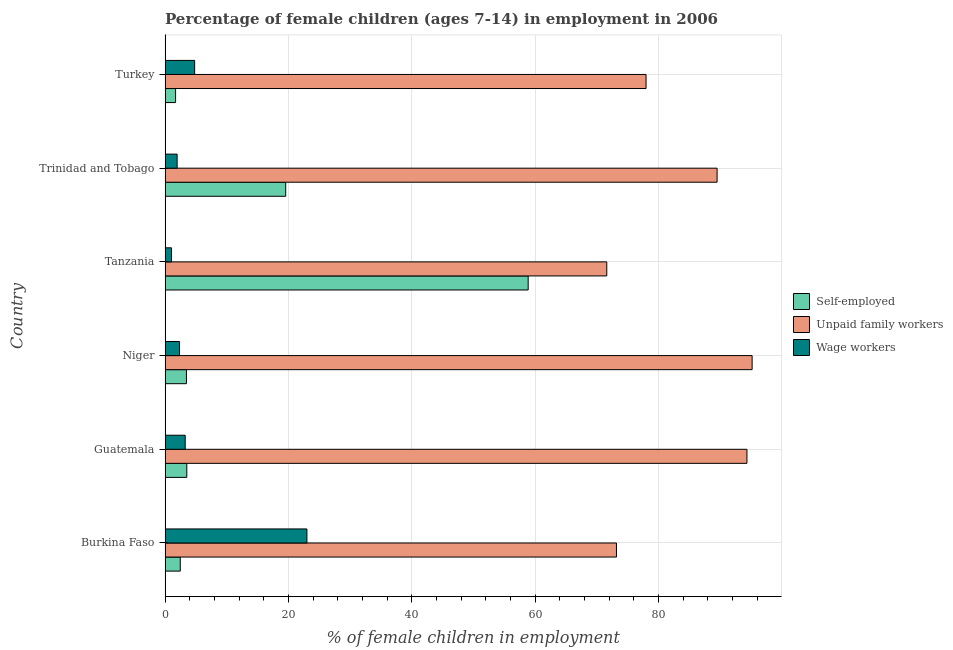How many bars are there on the 4th tick from the top?
Provide a succinct answer. 3. What is the label of the 2nd group of bars from the top?
Your response must be concise. Trinidad and Tobago. What is the percentage of children employed as unpaid family workers in Trinidad and Tobago?
Offer a very short reply. 89.52. Across all countries, what is the maximum percentage of self employed children?
Keep it short and to the point. 58.88. Across all countries, what is the minimum percentage of self employed children?
Provide a short and direct response. 1.7. In which country was the percentage of self employed children maximum?
Offer a very short reply. Tanzania. In which country was the percentage of self employed children minimum?
Provide a short and direct response. Turkey. What is the total percentage of children employed as wage workers in the graph?
Give a very brief answer. 36.38. What is the difference between the percentage of self employed children in Tanzania and that in Turkey?
Make the answer very short. 57.18. What is the difference between the percentage of children employed as wage workers in Tanzania and the percentage of self employed children in Burkina Faso?
Offer a very short reply. -1.42. What is the average percentage of self employed children per country?
Your answer should be compact. 14.93. What is the difference between the percentage of self employed children and percentage of children employed as unpaid family workers in Turkey?
Provide a succinct answer. -76.3. In how many countries, is the percentage of children employed as unpaid family workers greater than 40 %?
Your response must be concise. 6. What is the ratio of the percentage of self employed children in Tanzania to that in Trinidad and Tobago?
Provide a short and direct response. 3.01. Is the difference between the percentage of self employed children in Guatemala and Tanzania greater than the difference between the percentage of children employed as wage workers in Guatemala and Tanzania?
Make the answer very short. No. What is the difference between the highest and the second highest percentage of children employed as unpaid family workers?
Provide a succinct answer. 0.84. What is the difference between the highest and the lowest percentage of children employed as wage workers?
Your answer should be very brief. 21.96. In how many countries, is the percentage of self employed children greater than the average percentage of self employed children taken over all countries?
Offer a terse response. 2. Is the sum of the percentage of self employed children in Tanzania and Turkey greater than the maximum percentage of children employed as wage workers across all countries?
Provide a succinct answer. Yes. What does the 3rd bar from the top in Trinidad and Tobago represents?
Your response must be concise. Self-employed. What does the 2nd bar from the bottom in Tanzania represents?
Provide a short and direct response. Unpaid family workers. Is it the case that in every country, the sum of the percentage of self employed children and percentage of children employed as unpaid family workers is greater than the percentage of children employed as wage workers?
Your answer should be compact. Yes. How many bars are there?
Your response must be concise. 18. Are all the bars in the graph horizontal?
Your answer should be very brief. Yes. How many countries are there in the graph?
Keep it short and to the point. 6. What is the difference between two consecutive major ticks on the X-axis?
Your response must be concise. 20. Are the values on the major ticks of X-axis written in scientific E-notation?
Your response must be concise. No. Does the graph contain grids?
Give a very brief answer. Yes. How are the legend labels stacked?
Your answer should be very brief. Vertical. What is the title of the graph?
Offer a terse response. Percentage of female children (ages 7-14) in employment in 2006. Does "Injury" appear as one of the legend labels in the graph?
Your answer should be very brief. No. What is the label or title of the X-axis?
Offer a terse response. % of female children in employment. What is the % of female children in employment of Self-employed in Burkina Faso?
Ensure brevity in your answer.  2.46. What is the % of female children in employment in Unpaid family workers in Burkina Faso?
Your answer should be compact. 73.2. What is the % of female children in employment in Wage workers in Burkina Faso?
Your answer should be compact. 23. What is the % of female children in employment of Self-employed in Guatemala?
Give a very brief answer. 3.52. What is the % of female children in employment of Unpaid family workers in Guatemala?
Your answer should be compact. 94.36. What is the % of female children in employment of Wage workers in Guatemala?
Your answer should be very brief. 3.26. What is the % of female children in employment in Self-employed in Niger?
Offer a terse response. 3.46. What is the % of female children in employment in Unpaid family workers in Niger?
Your answer should be compact. 95.2. What is the % of female children in employment of Wage workers in Niger?
Your response must be concise. 2.34. What is the % of female children in employment of Self-employed in Tanzania?
Provide a short and direct response. 58.88. What is the % of female children in employment in Unpaid family workers in Tanzania?
Give a very brief answer. 71.63. What is the % of female children in employment in Self-employed in Trinidad and Tobago?
Ensure brevity in your answer.  19.56. What is the % of female children in employment in Unpaid family workers in Trinidad and Tobago?
Your response must be concise. 89.52. What is the % of female children in employment in Wage workers in Trinidad and Tobago?
Your answer should be compact. 1.95. What is the % of female children in employment in Self-employed in Turkey?
Provide a succinct answer. 1.7. What is the % of female children in employment in Unpaid family workers in Turkey?
Ensure brevity in your answer.  78. What is the % of female children in employment of Wage workers in Turkey?
Make the answer very short. 4.79. Across all countries, what is the maximum % of female children in employment of Self-employed?
Offer a terse response. 58.88. Across all countries, what is the maximum % of female children in employment in Unpaid family workers?
Offer a very short reply. 95.2. Across all countries, what is the maximum % of female children in employment of Wage workers?
Your answer should be very brief. 23. Across all countries, what is the minimum % of female children in employment of Unpaid family workers?
Provide a short and direct response. 71.63. What is the total % of female children in employment of Self-employed in the graph?
Make the answer very short. 89.58. What is the total % of female children in employment in Unpaid family workers in the graph?
Offer a terse response. 501.91. What is the total % of female children in employment in Wage workers in the graph?
Your answer should be very brief. 36.38. What is the difference between the % of female children in employment of Self-employed in Burkina Faso and that in Guatemala?
Give a very brief answer. -1.06. What is the difference between the % of female children in employment in Unpaid family workers in Burkina Faso and that in Guatemala?
Your answer should be very brief. -21.16. What is the difference between the % of female children in employment of Wage workers in Burkina Faso and that in Guatemala?
Give a very brief answer. 19.74. What is the difference between the % of female children in employment of Unpaid family workers in Burkina Faso and that in Niger?
Your answer should be very brief. -22. What is the difference between the % of female children in employment of Wage workers in Burkina Faso and that in Niger?
Your answer should be very brief. 20.66. What is the difference between the % of female children in employment in Self-employed in Burkina Faso and that in Tanzania?
Your answer should be compact. -56.42. What is the difference between the % of female children in employment in Unpaid family workers in Burkina Faso and that in Tanzania?
Your response must be concise. 1.57. What is the difference between the % of female children in employment of Wage workers in Burkina Faso and that in Tanzania?
Offer a very short reply. 21.96. What is the difference between the % of female children in employment in Self-employed in Burkina Faso and that in Trinidad and Tobago?
Ensure brevity in your answer.  -17.1. What is the difference between the % of female children in employment of Unpaid family workers in Burkina Faso and that in Trinidad and Tobago?
Ensure brevity in your answer.  -16.32. What is the difference between the % of female children in employment in Wage workers in Burkina Faso and that in Trinidad and Tobago?
Offer a very short reply. 21.05. What is the difference between the % of female children in employment of Self-employed in Burkina Faso and that in Turkey?
Your answer should be compact. 0.76. What is the difference between the % of female children in employment in Wage workers in Burkina Faso and that in Turkey?
Keep it short and to the point. 18.21. What is the difference between the % of female children in employment of Unpaid family workers in Guatemala and that in Niger?
Ensure brevity in your answer.  -0.84. What is the difference between the % of female children in employment of Self-employed in Guatemala and that in Tanzania?
Ensure brevity in your answer.  -55.36. What is the difference between the % of female children in employment of Unpaid family workers in Guatemala and that in Tanzania?
Your response must be concise. 22.73. What is the difference between the % of female children in employment in Wage workers in Guatemala and that in Tanzania?
Your answer should be very brief. 2.22. What is the difference between the % of female children in employment in Self-employed in Guatemala and that in Trinidad and Tobago?
Give a very brief answer. -16.04. What is the difference between the % of female children in employment in Unpaid family workers in Guatemala and that in Trinidad and Tobago?
Provide a succinct answer. 4.84. What is the difference between the % of female children in employment of Wage workers in Guatemala and that in Trinidad and Tobago?
Ensure brevity in your answer.  1.31. What is the difference between the % of female children in employment of Self-employed in Guatemala and that in Turkey?
Provide a short and direct response. 1.82. What is the difference between the % of female children in employment in Unpaid family workers in Guatemala and that in Turkey?
Make the answer very short. 16.36. What is the difference between the % of female children in employment in Wage workers in Guatemala and that in Turkey?
Provide a short and direct response. -1.53. What is the difference between the % of female children in employment in Self-employed in Niger and that in Tanzania?
Offer a very short reply. -55.42. What is the difference between the % of female children in employment in Unpaid family workers in Niger and that in Tanzania?
Your answer should be very brief. 23.57. What is the difference between the % of female children in employment of Self-employed in Niger and that in Trinidad and Tobago?
Provide a short and direct response. -16.1. What is the difference between the % of female children in employment of Unpaid family workers in Niger and that in Trinidad and Tobago?
Provide a succinct answer. 5.68. What is the difference between the % of female children in employment of Wage workers in Niger and that in Trinidad and Tobago?
Offer a terse response. 0.39. What is the difference between the % of female children in employment in Self-employed in Niger and that in Turkey?
Provide a short and direct response. 1.76. What is the difference between the % of female children in employment of Wage workers in Niger and that in Turkey?
Keep it short and to the point. -2.45. What is the difference between the % of female children in employment in Self-employed in Tanzania and that in Trinidad and Tobago?
Give a very brief answer. 39.32. What is the difference between the % of female children in employment of Unpaid family workers in Tanzania and that in Trinidad and Tobago?
Make the answer very short. -17.89. What is the difference between the % of female children in employment of Wage workers in Tanzania and that in Trinidad and Tobago?
Give a very brief answer. -0.91. What is the difference between the % of female children in employment in Self-employed in Tanzania and that in Turkey?
Give a very brief answer. 57.18. What is the difference between the % of female children in employment of Unpaid family workers in Tanzania and that in Turkey?
Your answer should be very brief. -6.37. What is the difference between the % of female children in employment of Wage workers in Tanzania and that in Turkey?
Offer a very short reply. -3.75. What is the difference between the % of female children in employment of Self-employed in Trinidad and Tobago and that in Turkey?
Give a very brief answer. 17.86. What is the difference between the % of female children in employment in Unpaid family workers in Trinidad and Tobago and that in Turkey?
Provide a succinct answer. 11.52. What is the difference between the % of female children in employment of Wage workers in Trinidad and Tobago and that in Turkey?
Give a very brief answer. -2.84. What is the difference between the % of female children in employment in Self-employed in Burkina Faso and the % of female children in employment in Unpaid family workers in Guatemala?
Ensure brevity in your answer.  -91.9. What is the difference between the % of female children in employment in Self-employed in Burkina Faso and the % of female children in employment in Wage workers in Guatemala?
Give a very brief answer. -0.8. What is the difference between the % of female children in employment of Unpaid family workers in Burkina Faso and the % of female children in employment of Wage workers in Guatemala?
Provide a short and direct response. 69.94. What is the difference between the % of female children in employment of Self-employed in Burkina Faso and the % of female children in employment of Unpaid family workers in Niger?
Your answer should be compact. -92.74. What is the difference between the % of female children in employment of Self-employed in Burkina Faso and the % of female children in employment of Wage workers in Niger?
Ensure brevity in your answer.  0.12. What is the difference between the % of female children in employment of Unpaid family workers in Burkina Faso and the % of female children in employment of Wage workers in Niger?
Give a very brief answer. 70.86. What is the difference between the % of female children in employment of Self-employed in Burkina Faso and the % of female children in employment of Unpaid family workers in Tanzania?
Ensure brevity in your answer.  -69.17. What is the difference between the % of female children in employment in Self-employed in Burkina Faso and the % of female children in employment in Wage workers in Tanzania?
Make the answer very short. 1.42. What is the difference between the % of female children in employment in Unpaid family workers in Burkina Faso and the % of female children in employment in Wage workers in Tanzania?
Your answer should be compact. 72.16. What is the difference between the % of female children in employment in Self-employed in Burkina Faso and the % of female children in employment in Unpaid family workers in Trinidad and Tobago?
Ensure brevity in your answer.  -87.06. What is the difference between the % of female children in employment in Self-employed in Burkina Faso and the % of female children in employment in Wage workers in Trinidad and Tobago?
Make the answer very short. 0.51. What is the difference between the % of female children in employment of Unpaid family workers in Burkina Faso and the % of female children in employment of Wage workers in Trinidad and Tobago?
Your response must be concise. 71.25. What is the difference between the % of female children in employment of Self-employed in Burkina Faso and the % of female children in employment of Unpaid family workers in Turkey?
Keep it short and to the point. -75.54. What is the difference between the % of female children in employment of Self-employed in Burkina Faso and the % of female children in employment of Wage workers in Turkey?
Ensure brevity in your answer.  -2.33. What is the difference between the % of female children in employment in Unpaid family workers in Burkina Faso and the % of female children in employment in Wage workers in Turkey?
Offer a terse response. 68.41. What is the difference between the % of female children in employment of Self-employed in Guatemala and the % of female children in employment of Unpaid family workers in Niger?
Ensure brevity in your answer.  -91.68. What is the difference between the % of female children in employment of Self-employed in Guatemala and the % of female children in employment of Wage workers in Niger?
Your answer should be very brief. 1.18. What is the difference between the % of female children in employment in Unpaid family workers in Guatemala and the % of female children in employment in Wage workers in Niger?
Offer a terse response. 92.02. What is the difference between the % of female children in employment in Self-employed in Guatemala and the % of female children in employment in Unpaid family workers in Tanzania?
Provide a short and direct response. -68.11. What is the difference between the % of female children in employment in Self-employed in Guatemala and the % of female children in employment in Wage workers in Tanzania?
Your answer should be compact. 2.48. What is the difference between the % of female children in employment in Unpaid family workers in Guatemala and the % of female children in employment in Wage workers in Tanzania?
Offer a very short reply. 93.32. What is the difference between the % of female children in employment in Self-employed in Guatemala and the % of female children in employment in Unpaid family workers in Trinidad and Tobago?
Your response must be concise. -86. What is the difference between the % of female children in employment in Self-employed in Guatemala and the % of female children in employment in Wage workers in Trinidad and Tobago?
Offer a very short reply. 1.57. What is the difference between the % of female children in employment in Unpaid family workers in Guatemala and the % of female children in employment in Wage workers in Trinidad and Tobago?
Your response must be concise. 92.41. What is the difference between the % of female children in employment in Self-employed in Guatemala and the % of female children in employment in Unpaid family workers in Turkey?
Provide a succinct answer. -74.48. What is the difference between the % of female children in employment of Self-employed in Guatemala and the % of female children in employment of Wage workers in Turkey?
Provide a short and direct response. -1.27. What is the difference between the % of female children in employment of Unpaid family workers in Guatemala and the % of female children in employment of Wage workers in Turkey?
Your answer should be very brief. 89.57. What is the difference between the % of female children in employment in Self-employed in Niger and the % of female children in employment in Unpaid family workers in Tanzania?
Provide a short and direct response. -68.17. What is the difference between the % of female children in employment of Self-employed in Niger and the % of female children in employment of Wage workers in Tanzania?
Provide a succinct answer. 2.42. What is the difference between the % of female children in employment of Unpaid family workers in Niger and the % of female children in employment of Wage workers in Tanzania?
Ensure brevity in your answer.  94.16. What is the difference between the % of female children in employment of Self-employed in Niger and the % of female children in employment of Unpaid family workers in Trinidad and Tobago?
Your response must be concise. -86.06. What is the difference between the % of female children in employment in Self-employed in Niger and the % of female children in employment in Wage workers in Trinidad and Tobago?
Offer a very short reply. 1.51. What is the difference between the % of female children in employment in Unpaid family workers in Niger and the % of female children in employment in Wage workers in Trinidad and Tobago?
Provide a succinct answer. 93.25. What is the difference between the % of female children in employment of Self-employed in Niger and the % of female children in employment of Unpaid family workers in Turkey?
Ensure brevity in your answer.  -74.54. What is the difference between the % of female children in employment of Self-employed in Niger and the % of female children in employment of Wage workers in Turkey?
Keep it short and to the point. -1.33. What is the difference between the % of female children in employment of Unpaid family workers in Niger and the % of female children in employment of Wage workers in Turkey?
Ensure brevity in your answer.  90.41. What is the difference between the % of female children in employment in Self-employed in Tanzania and the % of female children in employment in Unpaid family workers in Trinidad and Tobago?
Give a very brief answer. -30.64. What is the difference between the % of female children in employment of Self-employed in Tanzania and the % of female children in employment of Wage workers in Trinidad and Tobago?
Make the answer very short. 56.93. What is the difference between the % of female children in employment of Unpaid family workers in Tanzania and the % of female children in employment of Wage workers in Trinidad and Tobago?
Your response must be concise. 69.68. What is the difference between the % of female children in employment of Self-employed in Tanzania and the % of female children in employment of Unpaid family workers in Turkey?
Your answer should be very brief. -19.12. What is the difference between the % of female children in employment of Self-employed in Tanzania and the % of female children in employment of Wage workers in Turkey?
Make the answer very short. 54.09. What is the difference between the % of female children in employment of Unpaid family workers in Tanzania and the % of female children in employment of Wage workers in Turkey?
Your response must be concise. 66.84. What is the difference between the % of female children in employment in Self-employed in Trinidad and Tobago and the % of female children in employment in Unpaid family workers in Turkey?
Give a very brief answer. -58.44. What is the difference between the % of female children in employment of Self-employed in Trinidad and Tobago and the % of female children in employment of Wage workers in Turkey?
Make the answer very short. 14.77. What is the difference between the % of female children in employment in Unpaid family workers in Trinidad and Tobago and the % of female children in employment in Wage workers in Turkey?
Provide a short and direct response. 84.73. What is the average % of female children in employment in Self-employed per country?
Your answer should be very brief. 14.93. What is the average % of female children in employment of Unpaid family workers per country?
Your answer should be compact. 83.65. What is the average % of female children in employment of Wage workers per country?
Give a very brief answer. 6.06. What is the difference between the % of female children in employment of Self-employed and % of female children in employment of Unpaid family workers in Burkina Faso?
Offer a very short reply. -70.74. What is the difference between the % of female children in employment in Self-employed and % of female children in employment in Wage workers in Burkina Faso?
Offer a terse response. -20.54. What is the difference between the % of female children in employment of Unpaid family workers and % of female children in employment of Wage workers in Burkina Faso?
Keep it short and to the point. 50.2. What is the difference between the % of female children in employment of Self-employed and % of female children in employment of Unpaid family workers in Guatemala?
Offer a terse response. -90.84. What is the difference between the % of female children in employment in Self-employed and % of female children in employment in Wage workers in Guatemala?
Give a very brief answer. 0.26. What is the difference between the % of female children in employment of Unpaid family workers and % of female children in employment of Wage workers in Guatemala?
Give a very brief answer. 91.1. What is the difference between the % of female children in employment of Self-employed and % of female children in employment of Unpaid family workers in Niger?
Provide a short and direct response. -91.74. What is the difference between the % of female children in employment of Self-employed and % of female children in employment of Wage workers in Niger?
Offer a terse response. 1.12. What is the difference between the % of female children in employment in Unpaid family workers and % of female children in employment in Wage workers in Niger?
Provide a succinct answer. 92.86. What is the difference between the % of female children in employment in Self-employed and % of female children in employment in Unpaid family workers in Tanzania?
Keep it short and to the point. -12.75. What is the difference between the % of female children in employment in Self-employed and % of female children in employment in Wage workers in Tanzania?
Your response must be concise. 57.84. What is the difference between the % of female children in employment of Unpaid family workers and % of female children in employment of Wage workers in Tanzania?
Your answer should be very brief. 70.59. What is the difference between the % of female children in employment of Self-employed and % of female children in employment of Unpaid family workers in Trinidad and Tobago?
Offer a very short reply. -69.96. What is the difference between the % of female children in employment of Self-employed and % of female children in employment of Wage workers in Trinidad and Tobago?
Your answer should be compact. 17.61. What is the difference between the % of female children in employment of Unpaid family workers and % of female children in employment of Wage workers in Trinidad and Tobago?
Your answer should be compact. 87.57. What is the difference between the % of female children in employment in Self-employed and % of female children in employment in Unpaid family workers in Turkey?
Your answer should be compact. -76.3. What is the difference between the % of female children in employment in Self-employed and % of female children in employment in Wage workers in Turkey?
Your answer should be compact. -3.09. What is the difference between the % of female children in employment of Unpaid family workers and % of female children in employment of Wage workers in Turkey?
Ensure brevity in your answer.  73.21. What is the ratio of the % of female children in employment of Self-employed in Burkina Faso to that in Guatemala?
Give a very brief answer. 0.7. What is the ratio of the % of female children in employment of Unpaid family workers in Burkina Faso to that in Guatemala?
Make the answer very short. 0.78. What is the ratio of the % of female children in employment of Wage workers in Burkina Faso to that in Guatemala?
Offer a terse response. 7.06. What is the ratio of the % of female children in employment in Self-employed in Burkina Faso to that in Niger?
Keep it short and to the point. 0.71. What is the ratio of the % of female children in employment of Unpaid family workers in Burkina Faso to that in Niger?
Ensure brevity in your answer.  0.77. What is the ratio of the % of female children in employment in Wage workers in Burkina Faso to that in Niger?
Your response must be concise. 9.83. What is the ratio of the % of female children in employment of Self-employed in Burkina Faso to that in Tanzania?
Keep it short and to the point. 0.04. What is the ratio of the % of female children in employment of Unpaid family workers in Burkina Faso to that in Tanzania?
Provide a short and direct response. 1.02. What is the ratio of the % of female children in employment in Wage workers in Burkina Faso to that in Tanzania?
Make the answer very short. 22.12. What is the ratio of the % of female children in employment in Self-employed in Burkina Faso to that in Trinidad and Tobago?
Provide a succinct answer. 0.13. What is the ratio of the % of female children in employment in Unpaid family workers in Burkina Faso to that in Trinidad and Tobago?
Give a very brief answer. 0.82. What is the ratio of the % of female children in employment in Wage workers in Burkina Faso to that in Trinidad and Tobago?
Offer a very short reply. 11.79. What is the ratio of the % of female children in employment of Self-employed in Burkina Faso to that in Turkey?
Your answer should be compact. 1.45. What is the ratio of the % of female children in employment of Unpaid family workers in Burkina Faso to that in Turkey?
Give a very brief answer. 0.94. What is the ratio of the % of female children in employment in Wage workers in Burkina Faso to that in Turkey?
Make the answer very short. 4.8. What is the ratio of the % of female children in employment in Self-employed in Guatemala to that in Niger?
Provide a succinct answer. 1.02. What is the ratio of the % of female children in employment in Wage workers in Guatemala to that in Niger?
Provide a short and direct response. 1.39. What is the ratio of the % of female children in employment of Self-employed in Guatemala to that in Tanzania?
Keep it short and to the point. 0.06. What is the ratio of the % of female children in employment of Unpaid family workers in Guatemala to that in Tanzania?
Provide a short and direct response. 1.32. What is the ratio of the % of female children in employment in Wage workers in Guatemala to that in Tanzania?
Ensure brevity in your answer.  3.13. What is the ratio of the % of female children in employment in Self-employed in Guatemala to that in Trinidad and Tobago?
Ensure brevity in your answer.  0.18. What is the ratio of the % of female children in employment in Unpaid family workers in Guatemala to that in Trinidad and Tobago?
Make the answer very short. 1.05. What is the ratio of the % of female children in employment in Wage workers in Guatemala to that in Trinidad and Tobago?
Provide a succinct answer. 1.67. What is the ratio of the % of female children in employment of Self-employed in Guatemala to that in Turkey?
Give a very brief answer. 2.07. What is the ratio of the % of female children in employment of Unpaid family workers in Guatemala to that in Turkey?
Provide a short and direct response. 1.21. What is the ratio of the % of female children in employment in Wage workers in Guatemala to that in Turkey?
Provide a succinct answer. 0.68. What is the ratio of the % of female children in employment of Self-employed in Niger to that in Tanzania?
Offer a very short reply. 0.06. What is the ratio of the % of female children in employment in Unpaid family workers in Niger to that in Tanzania?
Your answer should be very brief. 1.33. What is the ratio of the % of female children in employment in Wage workers in Niger to that in Tanzania?
Your response must be concise. 2.25. What is the ratio of the % of female children in employment in Self-employed in Niger to that in Trinidad and Tobago?
Offer a very short reply. 0.18. What is the ratio of the % of female children in employment in Unpaid family workers in Niger to that in Trinidad and Tobago?
Your response must be concise. 1.06. What is the ratio of the % of female children in employment in Self-employed in Niger to that in Turkey?
Ensure brevity in your answer.  2.04. What is the ratio of the % of female children in employment in Unpaid family workers in Niger to that in Turkey?
Provide a short and direct response. 1.22. What is the ratio of the % of female children in employment in Wage workers in Niger to that in Turkey?
Your answer should be very brief. 0.49. What is the ratio of the % of female children in employment in Self-employed in Tanzania to that in Trinidad and Tobago?
Ensure brevity in your answer.  3.01. What is the ratio of the % of female children in employment in Unpaid family workers in Tanzania to that in Trinidad and Tobago?
Provide a succinct answer. 0.8. What is the ratio of the % of female children in employment in Wage workers in Tanzania to that in Trinidad and Tobago?
Keep it short and to the point. 0.53. What is the ratio of the % of female children in employment of Self-employed in Tanzania to that in Turkey?
Keep it short and to the point. 34.64. What is the ratio of the % of female children in employment of Unpaid family workers in Tanzania to that in Turkey?
Offer a very short reply. 0.92. What is the ratio of the % of female children in employment in Wage workers in Tanzania to that in Turkey?
Your answer should be compact. 0.22. What is the ratio of the % of female children in employment of Self-employed in Trinidad and Tobago to that in Turkey?
Keep it short and to the point. 11.51. What is the ratio of the % of female children in employment of Unpaid family workers in Trinidad and Tobago to that in Turkey?
Your answer should be compact. 1.15. What is the ratio of the % of female children in employment in Wage workers in Trinidad and Tobago to that in Turkey?
Keep it short and to the point. 0.41. What is the difference between the highest and the second highest % of female children in employment in Self-employed?
Your response must be concise. 39.32. What is the difference between the highest and the second highest % of female children in employment in Unpaid family workers?
Ensure brevity in your answer.  0.84. What is the difference between the highest and the second highest % of female children in employment of Wage workers?
Your answer should be very brief. 18.21. What is the difference between the highest and the lowest % of female children in employment of Self-employed?
Give a very brief answer. 57.18. What is the difference between the highest and the lowest % of female children in employment of Unpaid family workers?
Ensure brevity in your answer.  23.57. What is the difference between the highest and the lowest % of female children in employment in Wage workers?
Offer a very short reply. 21.96. 